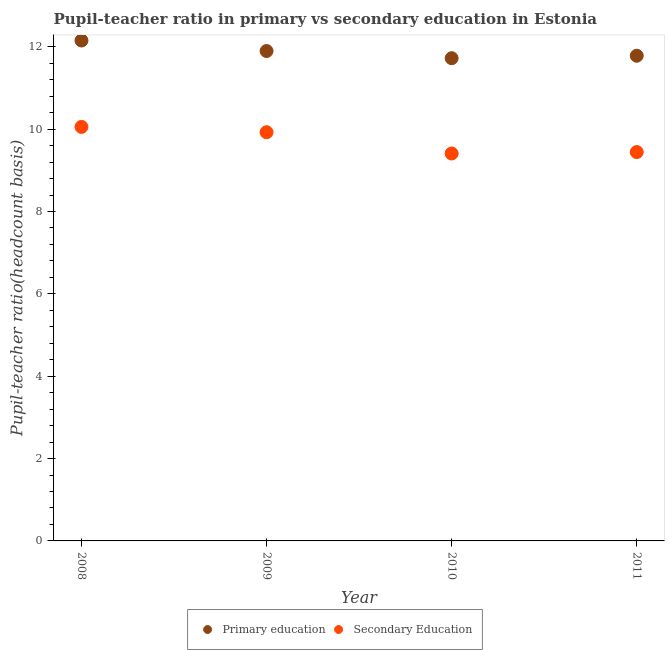What is the pupil teacher ratio on secondary education in 2010?
Your answer should be compact. 9.41. Across all years, what is the maximum pupil teacher ratio on secondary education?
Your answer should be compact. 10.05. Across all years, what is the minimum pupil teacher ratio on secondary education?
Provide a short and direct response. 9.41. What is the total pupil teacher ratio on secondary education in the graph?
Your answer should be compact. 38.83. What is the difference between the pupil-teacher ratio in primary education in 2008 and that in 2009?
Ensure brevity in your answer.  0.25. What is the difference between the pupil-teacher ratio in primary education in 2011 and the pupil teacher ratio on secondary education in 2008?
Make the answer very short. 1.73. What is the average pupil teacher ratio on secondary education per year?
Keep it short and to the point. 9.71. In the year 2008, what is the difference between the pupil-teacher ratio in primary education and pupil teacher ratio on secondary education?
Your answer should be compact. 2.1. In how many years, is the pupil-teacher ratio in primary education greater than 4.4?
Give a very brief answer. 4. What is the ratio of the pupil-teacher ratio in primary education in 2008 to that in 2010?
Make the answer very short. 1.04. Is the difference between the pupil-teacher ratio in primary education in 2008 and 2011 greater than the difference between the pupil teacher ratio on secondary education in 2008 and 2011?
Provide a short and direct response. No. What is the difference between the highest and the second highest pupil-teacher ratio in primary education?
Provide a succinct answer. 0.25. What is the difference between the highest and the lowest pupil-teacher ratio in primary education?
Give a very brief answer. 0.43. Is the pupil teacher ratio on secondary education strictly greater than the pupil-teacher ratio in primary education over the years?
Offer a very short reply. No. How many dotlines are there?
Provide a short and direct response. 2. Does the graph contain any zero values?
Your answer should be very brief. No. Does the graph contain grids?
Offer a terse response. No. Where does the legend appear in the graph?
Offer a very short reply. Bottom center. How are the legend labels stacked?
Make the answer very short. Horizontal. What is the title of the graph?
Give a very brief answer. Pupil-teacher ratio in primary vs secondary education in Estonia. Does "DAC donors" appear as one of the legend labels in the graph?
Offer a terse response. No. What is the label or title of the Y-axis?
Your answer should be very brief. Pupil-teacher ratio(headcount basis). What is the Pupil-teacher ratio(headcount basis) in Primary education in 2008?
Your answer should be very brief. 12.15. What is the Pupil-teacher ratio(headcount basis) in Secondary Education in 2008?
Make the answer very short. 10.05. What is the Pupil-teacher ratio(headcount basis) in Primary education in 2009?
Offer a very short reply. 11.9. What is the Pupil-teacher ratio(headcount basis) of Secondary Education in 2009?
Provide a succinct answer. 9.93. What is the Pupil-teacher ratio(headcount basis) in Primary education in 2010?
Make the answer very short. 11.72. What is the Pupil-teacher ratio(headcount basis) in Secondary Education in 2010?
Ensure brevity in your answer.  9.41. What is the Pupil-teacher ratio(headcount basis) in Primary education in 2011?
Offer a terse response. 11.78. What is the Pupil-teacher ratio(headcount basis) in Secondary Education in 2011?
Ensure brevity in your answer.  9.44. Across all years, what is the maximum Pupil-teacher ratio(headcount basis) of Primary education?
Your response must be concise. 12.15. Across all years, what is the maximum Pupil-teacher ratio(headcount basis) in Secondary Education?
Provide a succinct answer. 10.05. Across all years, what is the minimum Pupil-teacher ratio(headcount basis) of Primary education?
Provide a short and direct response. 11.72. Across all years, what is the minimum Pupil-teacher ratio(headcount basis) of Secondary Education?
Make the answer very short. 9.41. What is the total Pupil-teacher ratio(headcount basis) in Primary education in the graph?
Offer a terse response. 47.56. What is the total Pupil-teacher ratio(headcount basis) in Secondary Education in the graph?
Provide a succinct answer. 38.83. What is the difference between the Pupil-teacher ratio(headcount basis) in Primary education in 2008 and that in 2009?
Offer a terse response. 0.26. What is the difference between the Pupil-teacher ratio(headcount basis) of Secondary Education in 2008 and that in 2009?
Offer a terse response. 0.13. What is the difference between the Pupil-teacher ratio(headcount basis) of Primary education in 2008 and that in 2010?
Give a very brief answer. 0.43. What is the difference between the Pupil-teacher ratio(headcount basis) of Secondary Education in 2008 and that in 2010?
Ensure brevity in your answer.  0.65. What is the difference between the Pupil-teacher ratio(headcount basis) of Primary education in 2008 and that in 2011?
Your answer should be compact. 0.37. What is the difference between the Pupil-teacher ratio(headcount basis) of Secondary Education in 2008 and that in 2011?
Provide a short and direct response. 0.61. What is the difference between the Pupil-teacher ratio(headcount basis) of Primary education in 2009 and that in 2010?
Your answer should be very brief. 0.17. What is the difference between the Pupil-teacher ratio(headcount basis) of Secondary Education in 2009 and that in 2010?
Your answer should be compact. 0.52. What is the difference between the Pupil-teacher ratio(headcount basis) in Primary education in 2009 and that in 2011?
Give a very brief answer. 0.11. What is the difference between the Pupil-teacher ratio(headcount basis) of Secondary Education in 2009 and that in 2011?
Offer a very short reply. 0.48. What is the difference between the Pupil-teacher ratio(headcount basis) of Primary education in 2010 and that in 2011?
Offer a terse response. -0.06. What is the difference between the Pupil-teacher ratio(headcount basis) of Secondary Education in 2010 and that in 2011?
Your answer should be compact. -0.03. What is the difference between the Pupil-teacher ratio(headcount basis) of Primary education in 2008 and the Pupil-teacher ratio(headcount basis) of Secondary Education in 2009?
Your answer should be compact. 2.23. What is the difference between the Pupil-teacher ratio(headcount basis) in Primary education in 2008 and the Pupil-teacher ratio(headcount basis) in Secondary Education in 2010?
Your answer should be compact. 2.74. What is the difference between the Pupil-teacher ratio(headcount basis) in Primary education in 2008 and the Pupil-teacher ratio(headcount basis) in Secondary Education in 2011?
Your answer should be compact. 2.71. What is the difference between the Pupil-teacher ratio(headcount basis) in Primary education in 2009 and the Pupil-teacher ratio(headcount basis) in Secondary Education in 2010?
Provide a short and direct response. 2.49. What is the difference between the Pupil-teacher ratio(headcount basis) in Primary education in 2009 and the Pupil-teacher ratio(headcount basis) in Secondary Education in 2011?
Provide a succinct answer. 2.45. What is the difference between the Pupil-teacher ratio(headcount basis) of Primary education in 2010 and the Pupil-teacher ratio(headcount basis) of Secondary Education in 2011?
Your response must be concise. 2.28. What is the average Pupil-teacher ratio(headcount basis) in Primary education per year?
Your answer should be very brief. 11.89. What is the average Pupil-teacher ratio(headcount basis) of Secondary Education per year?
Offer a terse response. 9.71. In the year 2008, what is the difference between the Pupil-teacher ratio(headcount basis) of Primary education and Pupil-teacher ratio(headcount basis) of Secondary Education?
Your response must be concise. 2.1. In the year 2009, what is the difference between the Pupil-teacher ratio(headcount basis) of Primary education and Pupil-teacher ratio(headcount basis) of Secondary Education?
Offer a very short reply. 1.97. In the year 2010, what is the difference between the Pupil-teacher ratio(headcount basis) in Primary education and Pupil-teacher ratio(headcount basis) in Secondary Education?
Offer a very short reply. 2.31. In the year 2011, what is the difference between the Pupil-teacher ratio(headcount basis) in Primary education and Pupil-teacher ratio(headcount basis) in Secondary Education?
Offer a very short reply. 2.34. What is the ratio of the Pupil-teacher ratio(headcount basis) of Primary education in 2008 to that in 2009?
Give a very brief answer. 1.02. What is the ratio of the Pupil-teacher ratio(headcount basis) in Primary education in 2008 to that in 2010?
Provide a succinct answer. 1.04. What is the ratio of the Pupil-teacher ratio(headcount basis) of Secondary Education in 2008 to that in 2010?
Provide a short and direct response. 1.07. What is the ratio of the Pupil-teacher ratio(headcount basis) of Primary education in 2008 to that in 2011?
Your answer should be very brief. 1.03. What is the ratio of the Pupil-teacher ratio(headcount basis) of Secondary Education in 2008 to that in 2011?
Your answer should be very brief. 1.06. What is the ratio of the Pupil-teacher ratio(headcount basis) of Primary education in 2009 to that in 2010?
Provide a short and direct response. 1.01. What is the ratio of the Pupil-teacher ratio(headcount basis) in Secondary Education in 2009 to that in 2010?
Your answer should be compact. 1.05. What is the ratio of the Pupil-teacher ratio(headcount basis) in Primary education in 2009 to that in 2011?
Offer a terse response. 1.01. What is the ratio of the Pupil-teacher ratio(headcount basis) in Secondary Education in 2009 to that in 2011?
Offer a very short reply. 1.05. What is the ratio of the Pupil-teacher ratio(headcount basis) of Primary education in 2010 to that in 2011?
Offer a terse response. 0.99. What is the difference between the highest and the second highest Pupil-teacher ratio(headcount basis) of Primary education?
Provide a succinct answer. 0.26. What is the difference between the highest and the second highest Pupil-teacher ratio(headcount basis) of Secondary Education?
Offer a very short reply. 0.13. What is the difference between the highest and the lowest Pupil-teacher ratio(headcount basis) in Primary education?
Provide a succinct answer. 0.43. What is the difference between the highest and the lowest Pupil-teacher ratio(headcount basis) of Secondary Education?
Make the answer very short. 0.65. 